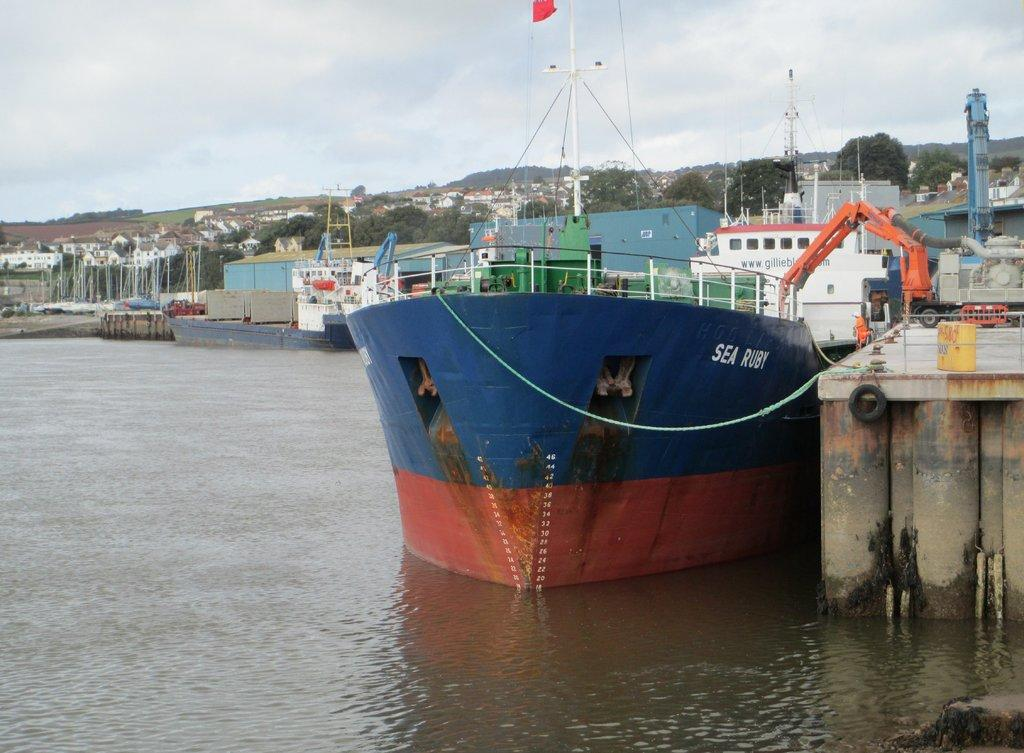What is the main subject of the image? The main subject of the image is a ship. What color is the ship? The ship is blue in color. What can be seen on the long back side of the ship? There are trees visible on the long back side of the ship. What is visible at the top of the image? The sky is visible at the top of the image. Can you tell me how many office desks are present in the image? There are no office desks present in the image; it features a blue ship with trees on its back side and a visible sky. What type of canvas is used to create the image? The image is not a painting on canvas; it is a photograph or digital image. 